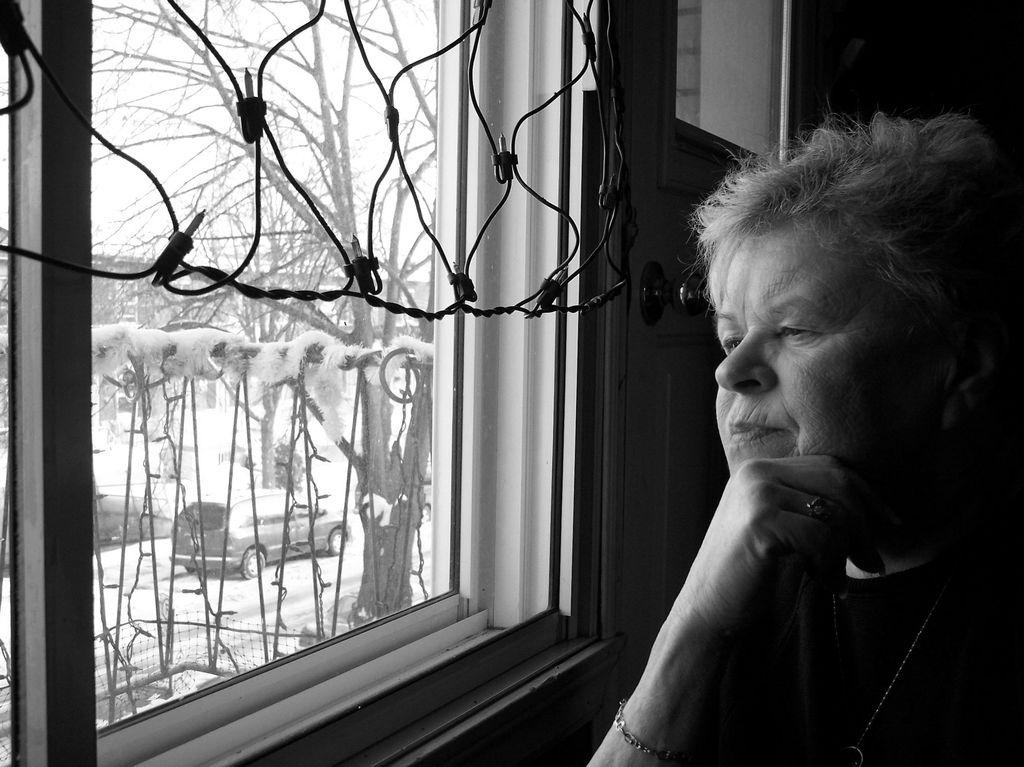Who is the main subject in the picture? There is a woman in the picture. What can be seen in the background of the picture? The background of the picture includes trees, a window, a vehicle, and the sky. What is the color scheme of the picture? The picture is black and white in color. What type of reaction does the stove have when the parent enters the room in the image? There is no stove or parent present in the image, so it is not possible to answer that question. 